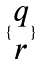<formula> <loc_0><loc_0><loc_500><loc_500>\{ \begin{matrix} q \\ r \end{matrix} \}</formula> 